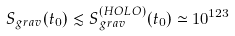<formula> <loc_0><loc_0><loc_500><loc_500>S _ { g r a v } ( t _ { 0 } ) \lesssim S _ { g r a v } ^ { ( H O L O ) } ( t _ { 0 } ) \simeq 1 0 ^ { 1 2 3 }</formula> 